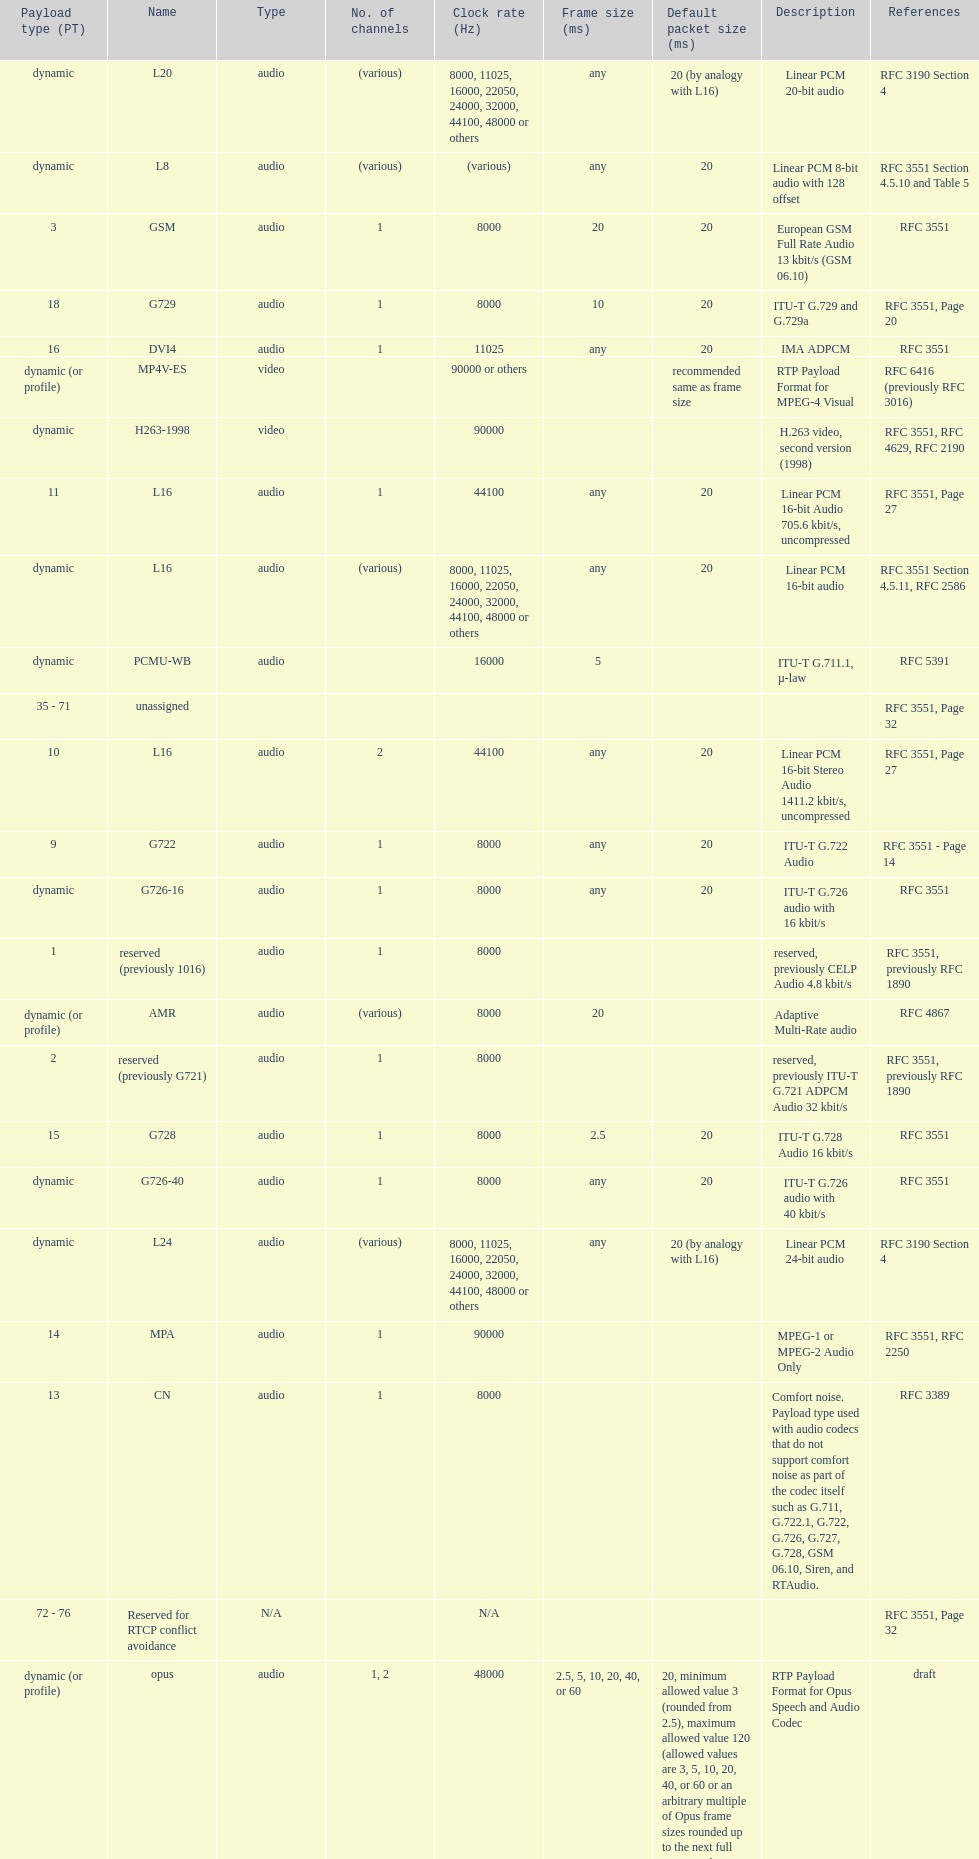The rtp/avp audio and video payload types include an audio type called qcelp and its frame size is how many ms? 20. 